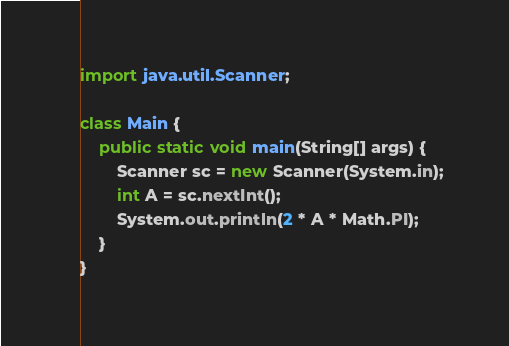Convert code to text. <code><loc_0><loc_0><loc_500><loc_500><_Java_>import java.util.Scanner;

class Main {
    public static void main(String[] args) {
        Scanner sc = new Scanner(System.in);
        int A = sc.nextInt();
        System.out.println(2 * A * Math.PI);
    }
}
</code> 